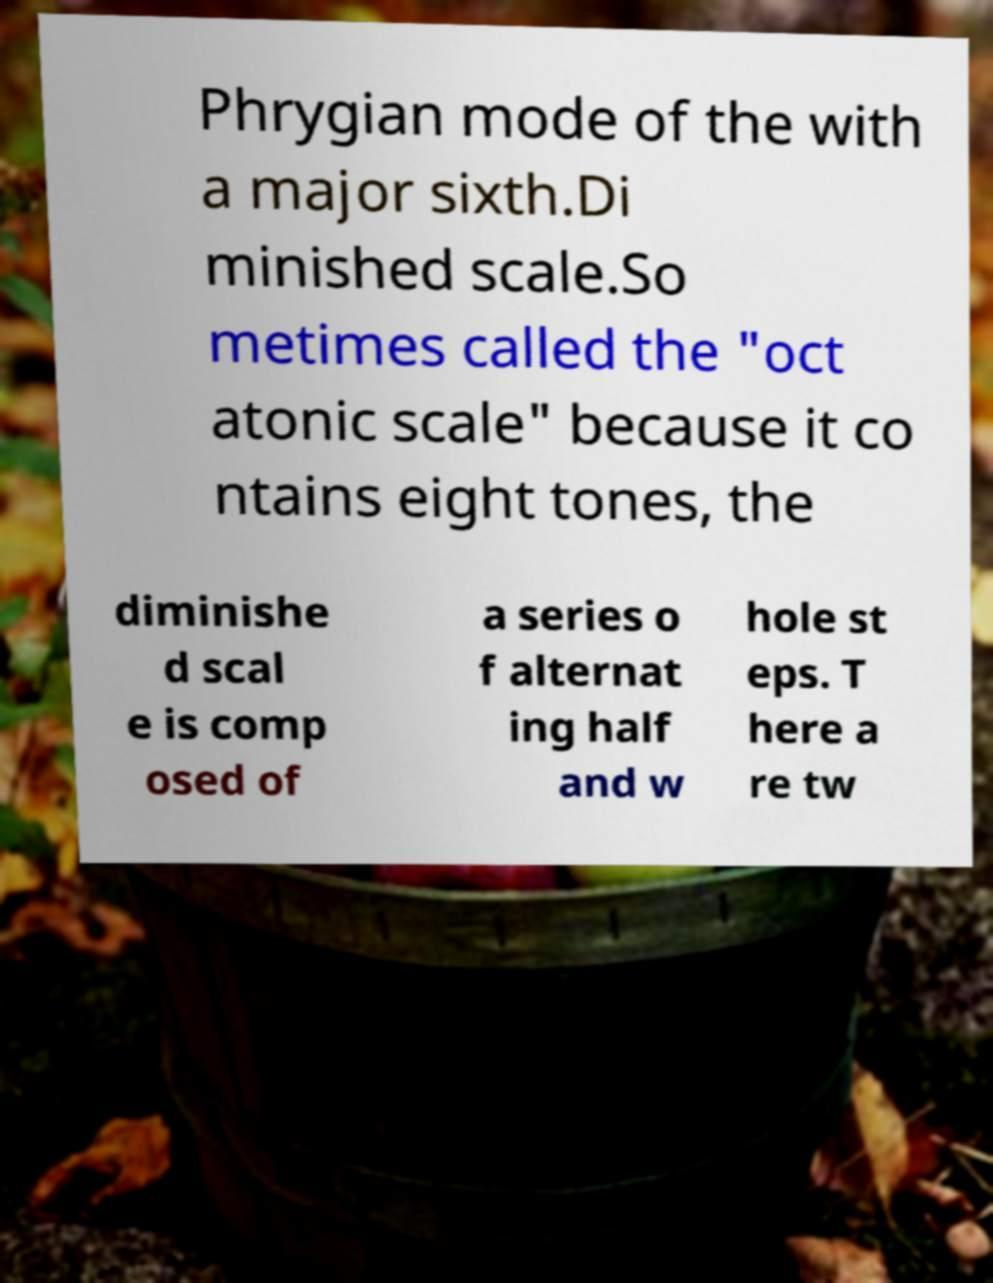Please identify and transcribe the text found in this image. Phrygian mode of the with a major sixth.Di minished scale.So metimes called the "oct atonic scale" because it co ntains eight tones, the diminishe d scal e is comp osed of a series o f alternat ing half and w hole st eps. T here a re tw 